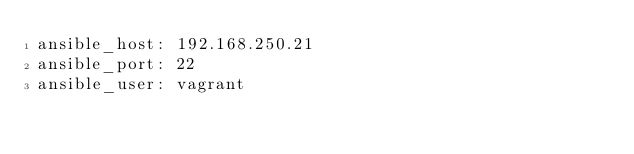<code> <loc_0><loc_0><loc_500><loc_500><_YAML_>ansible_host: 192.168.250.21
ansible_port: 22
ansible_user: vagrant
</code> 